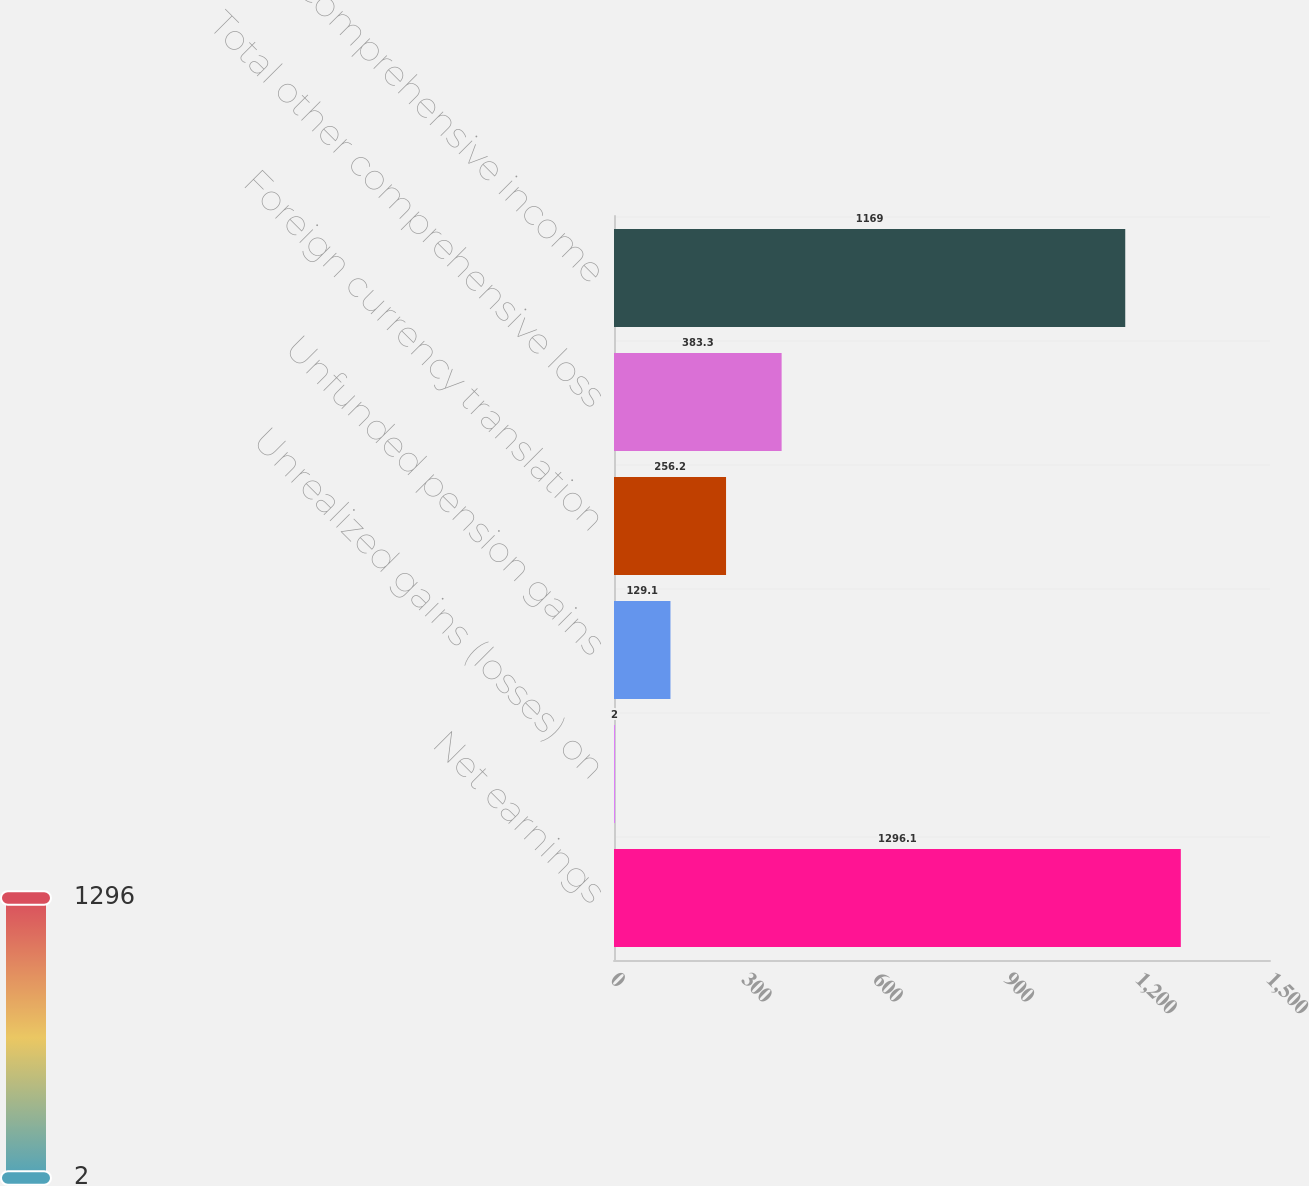Convert chart to OTSL. <chart><loc_0><loc_0><loc_500><loc_500><bar_chart><fcel>Net earnings<fcel>Unrealized gains (losses) on<fcel>Unfunded pension gains<fcel>Foreign currency translation<fcel>Total other comprehensive loss<fcel>Comprehensive income<nl><fcel>1296.1<fcel>2<fcel>129.1<fcel>256.2<fcel>383.3<fcel>1169<nl></chart> 